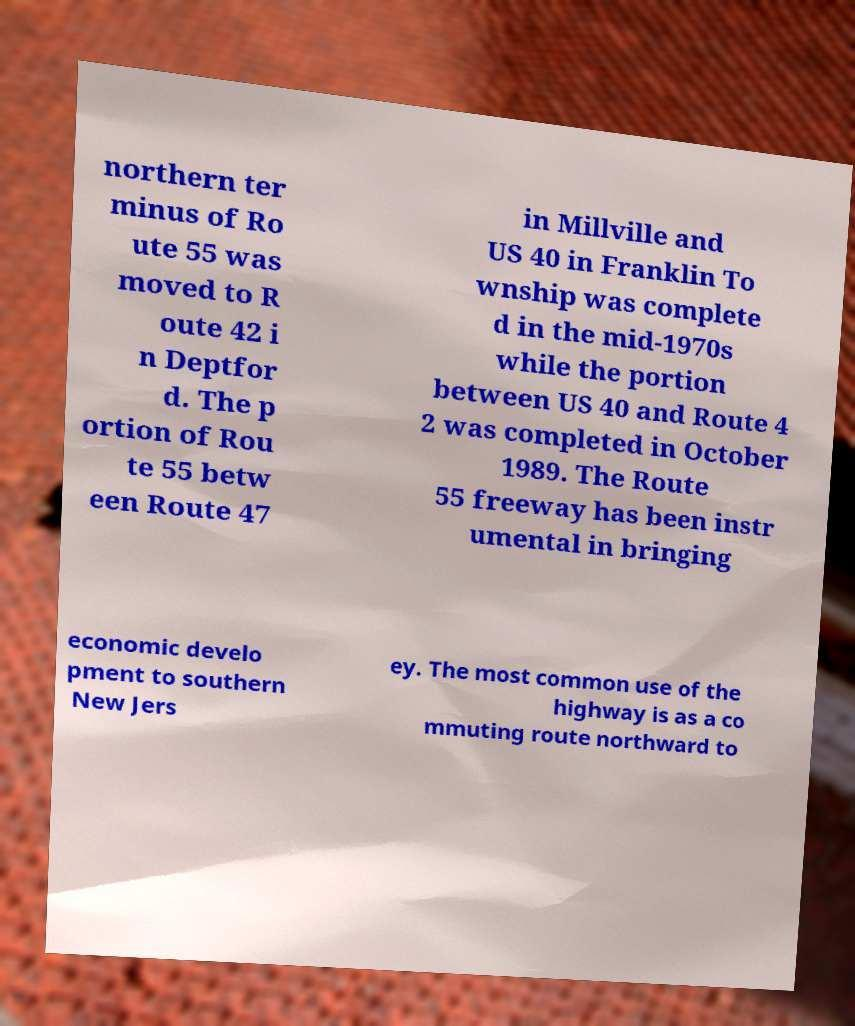Can you accurately transcribe the text from the provided image for me? northern ter minus of Ro ute 55 was moved to R oute 42 i n Deptfor d. The p ortion of Rou te 55 betw een Route 47 in Millville and US 40 in Franklin To wnship was complete d in the mid-1970s while the portion between US 40 and Route 4 2 was completed in October 1989. The Route 55 freeway has been instr umental in bringing economic develo pment to southern New Jers ey. The most common use of the highway is as a co mmuting route northward to 